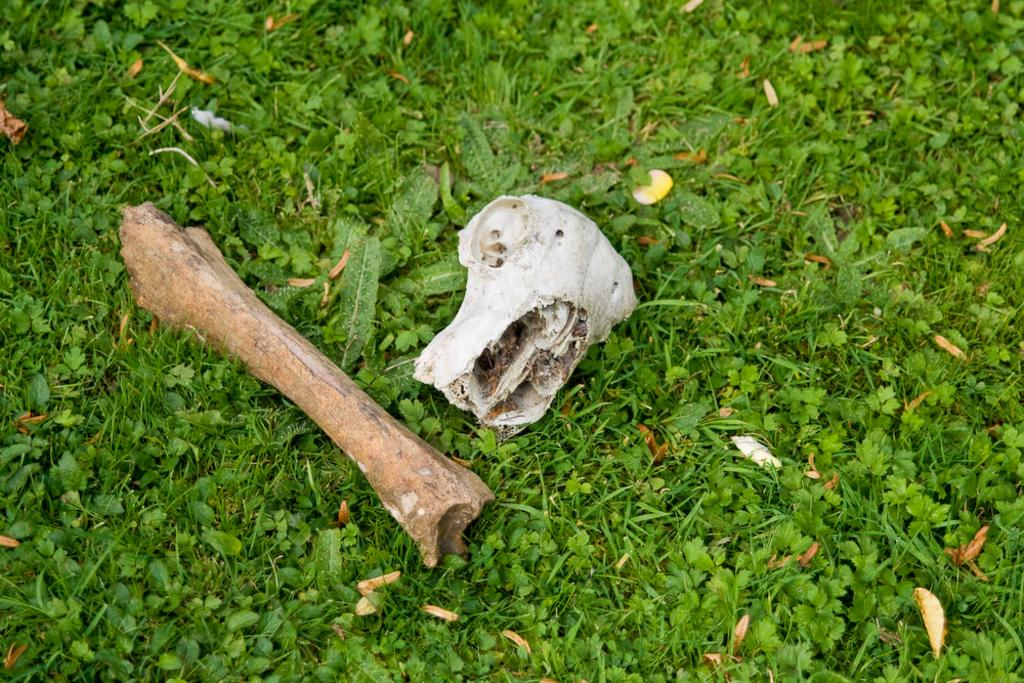Where was the image taken? The image was taken outdoors. What type of surface can be seen on the ground in the image? The ground in the image has grass. What objects are on the ground in the image? There are two bones on the ground in the image. What type of acoustics can be heard in the image? There is no sound or acoustics present in the image, as it is a still photograph. Can you see any popcorn in the image? There is no popcorn present in the image; it only features two bones on the grassy ground. 